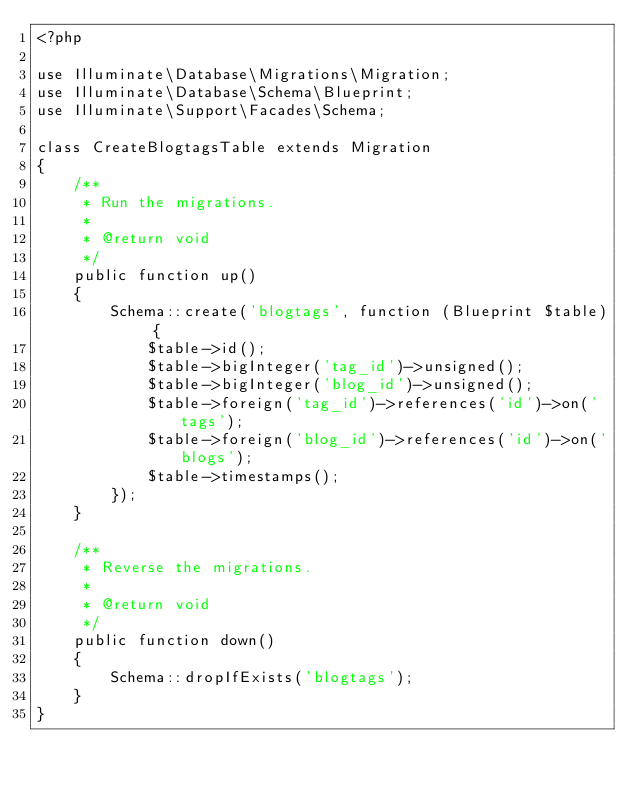Convert code to text. <code><loc_0><loc_0><loc_500><loc_500><_PHP_><?php

use Illuminate\Database\Migrations\Migration;
use Illuminate\Database\Schema\Blueprint;
use Illuminate\Support\Facades\Schema;

class CreateBlogtagsTable extends Migration
{
    /**
     * Run the migrations.
     *
     * @return void
     */
    public function up()
    {
        Schema::create('blogtags', function (Blueprint $table) {
            $table->id();
            $table->bigInteger('tag_id')->unsigned();
            $table->bigInteger('blog_id')->unsigned();
            $table->foreign('tag_id')->references('id')->on('tags');
            $table->foreign('blog_id')->references('id')->on('blogs');
            $table->timestamps();
        });
    }

    /**
     * Reverse the migrations.
     *
     * @return void
     */
    public function down()
    {
        Schema::dropIfExists('blogtags');
    }
}
</code> 